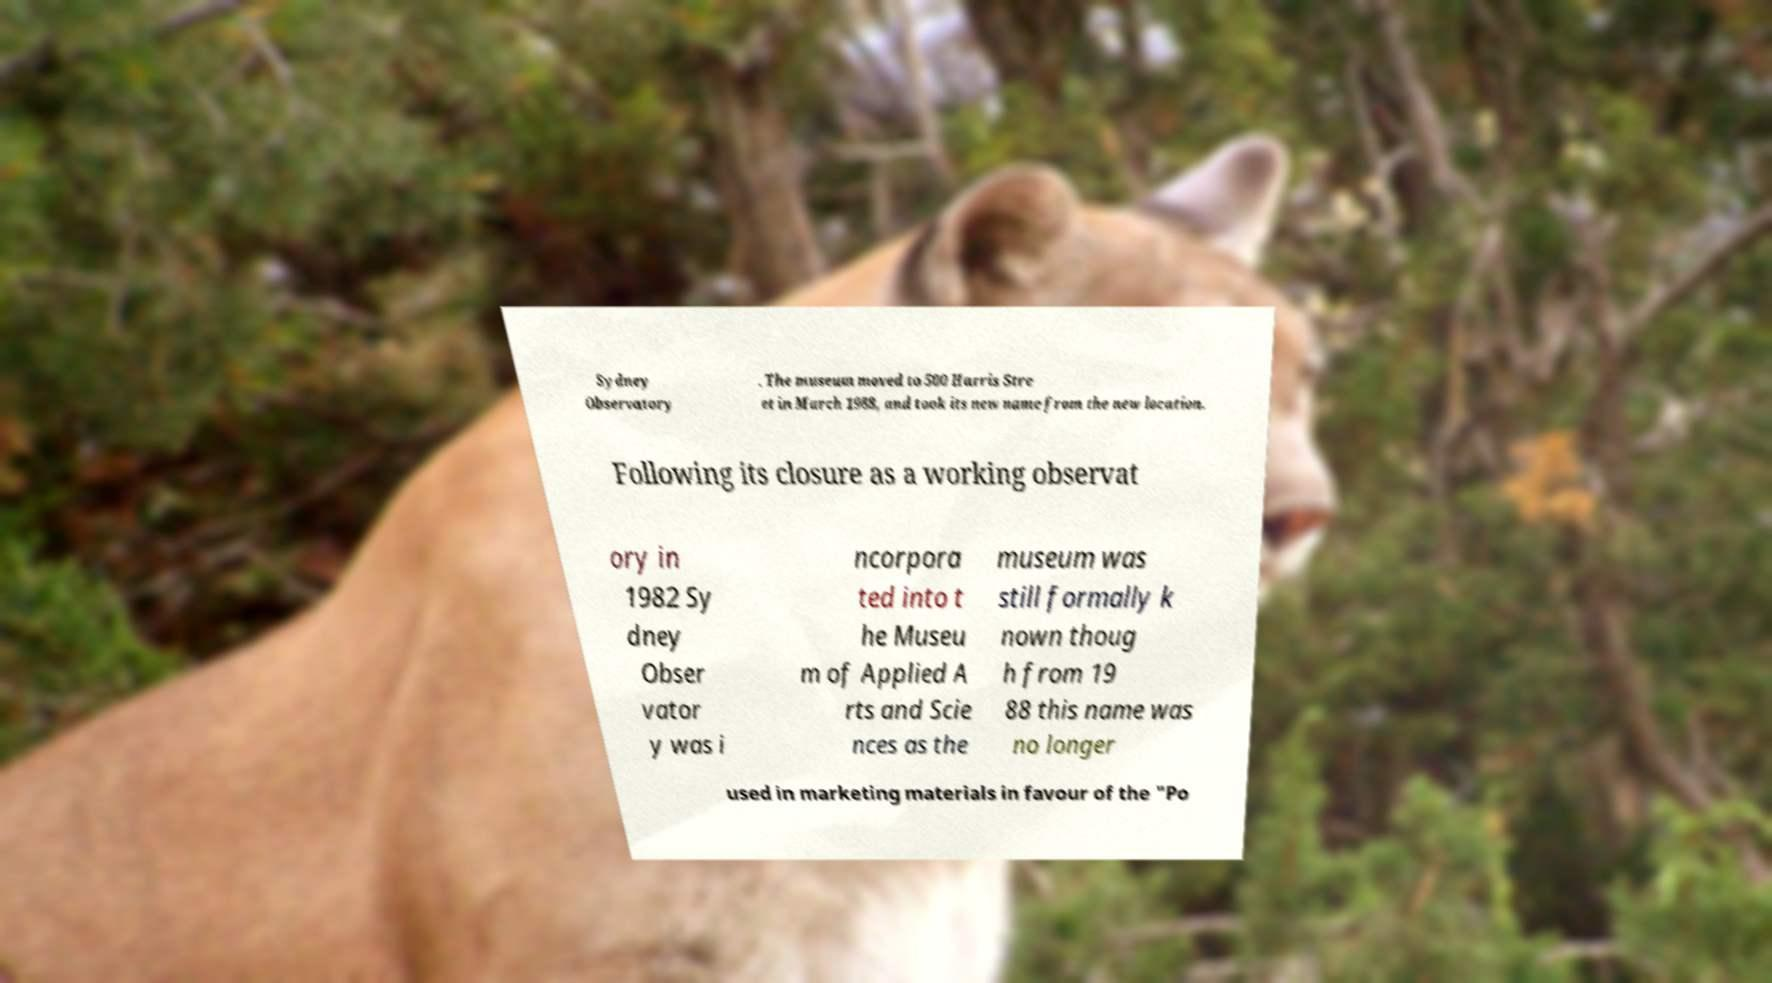I need the written content from this picture converted into text. Can you do that? Sydney Observatory . The museum moved to 500 Harris Stre et in March 1988, and took its new name from the new location. Following its closure as a working observat ory in 1982 Sy dney Obser vator y was i ncorpora ted into t he Museu m of Applied A rts and Scie nces as the museum was still formally k nown thoug h from 19 88 this name was no longer used in marketing materials in favour of the "Po 